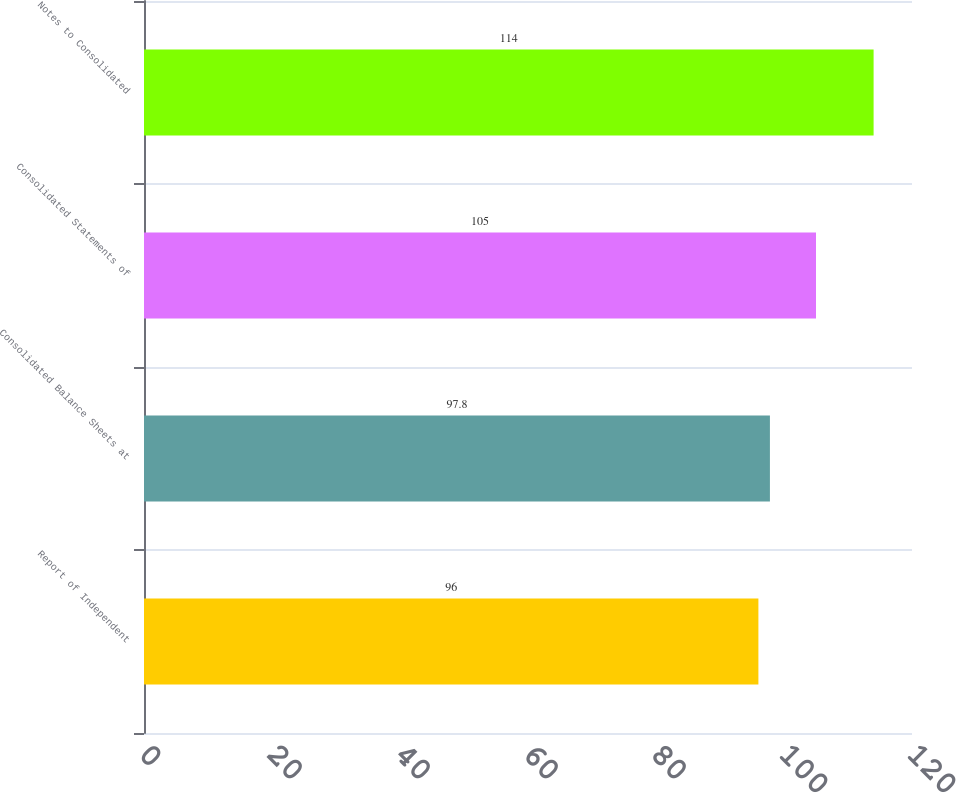Convert chart. <chart><loc_0><loc_0><loc_500><loc_500><bar_chart><fcel>Report of Independent<fcel>Consolidated Balance Sheets at<fcel>Consolidated Statements of<fcel>Notes to Consolidated<nl><fcel>96<fcel>97.8<fcel>105<fcel>114<nl></chart> 